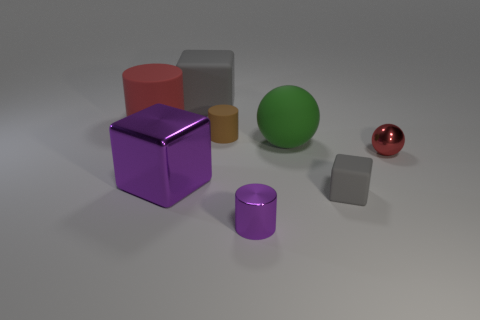Add 2 big gray metal spheres. How many objects exist? 10 Subtract all blocks. How many objects are left? 5 Add 3 small red metallic balls. How many small red metallic balls are left? 4 Add 2 small metal cylinders. How many small metal cylinders exist? 3 Subtract 1 purple blocks. How many objects are left? 7 Subtract all tiny green spheres. Subtract all big matte objects. How many objects are left? 5 